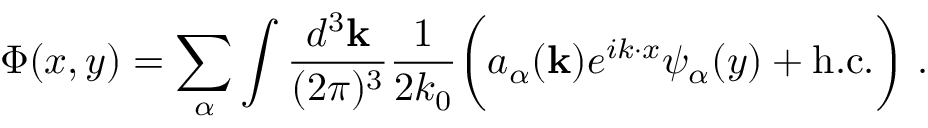<formula> <loc_0><loc_0><loc_500><loc_500>\Phi ( x , y ) = \sum _ { \alpha } \int \frac { d ^ { 3 } { k } } { ( 2 \pi ) ^ { 3 } } \frac { 1 } { 2 k _ { 0 } } \left ( a _ { \alpha } ( { k } ) e ^ { i k \cdot x } \psi _ { \alpha } ( y ) + h . c . \right ) \ .</formula> 